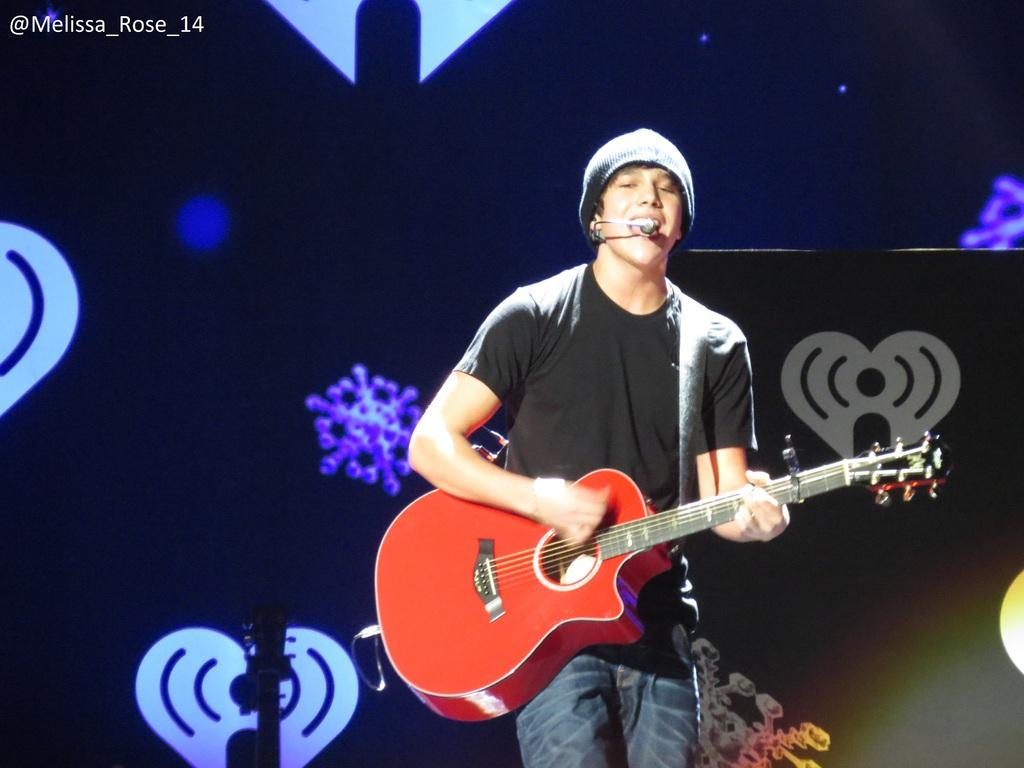What is the main subject of the image? The main subject of the image is a boy. What is the boy wearing in the image? The boy is wearing a black t-shirt in the image. What is the boy doing in the image? The boy is singing and playing a guitar in the image. What is the boy's posture in the image? The boy is standing in the image. What is on the boy's head in the image? The boy is wearing a cap on his head in the image. What can be seen in the background of the image? There is a black color light with designs in the background of the image. What type of country is depicted in the image? There is no country depicted in the image; it features a boy singing and playing a guitar. What kind of system is being used by the boy to play the guitar in the image? The image does not provide information about the type of system being used by the boy to play the guitar. 